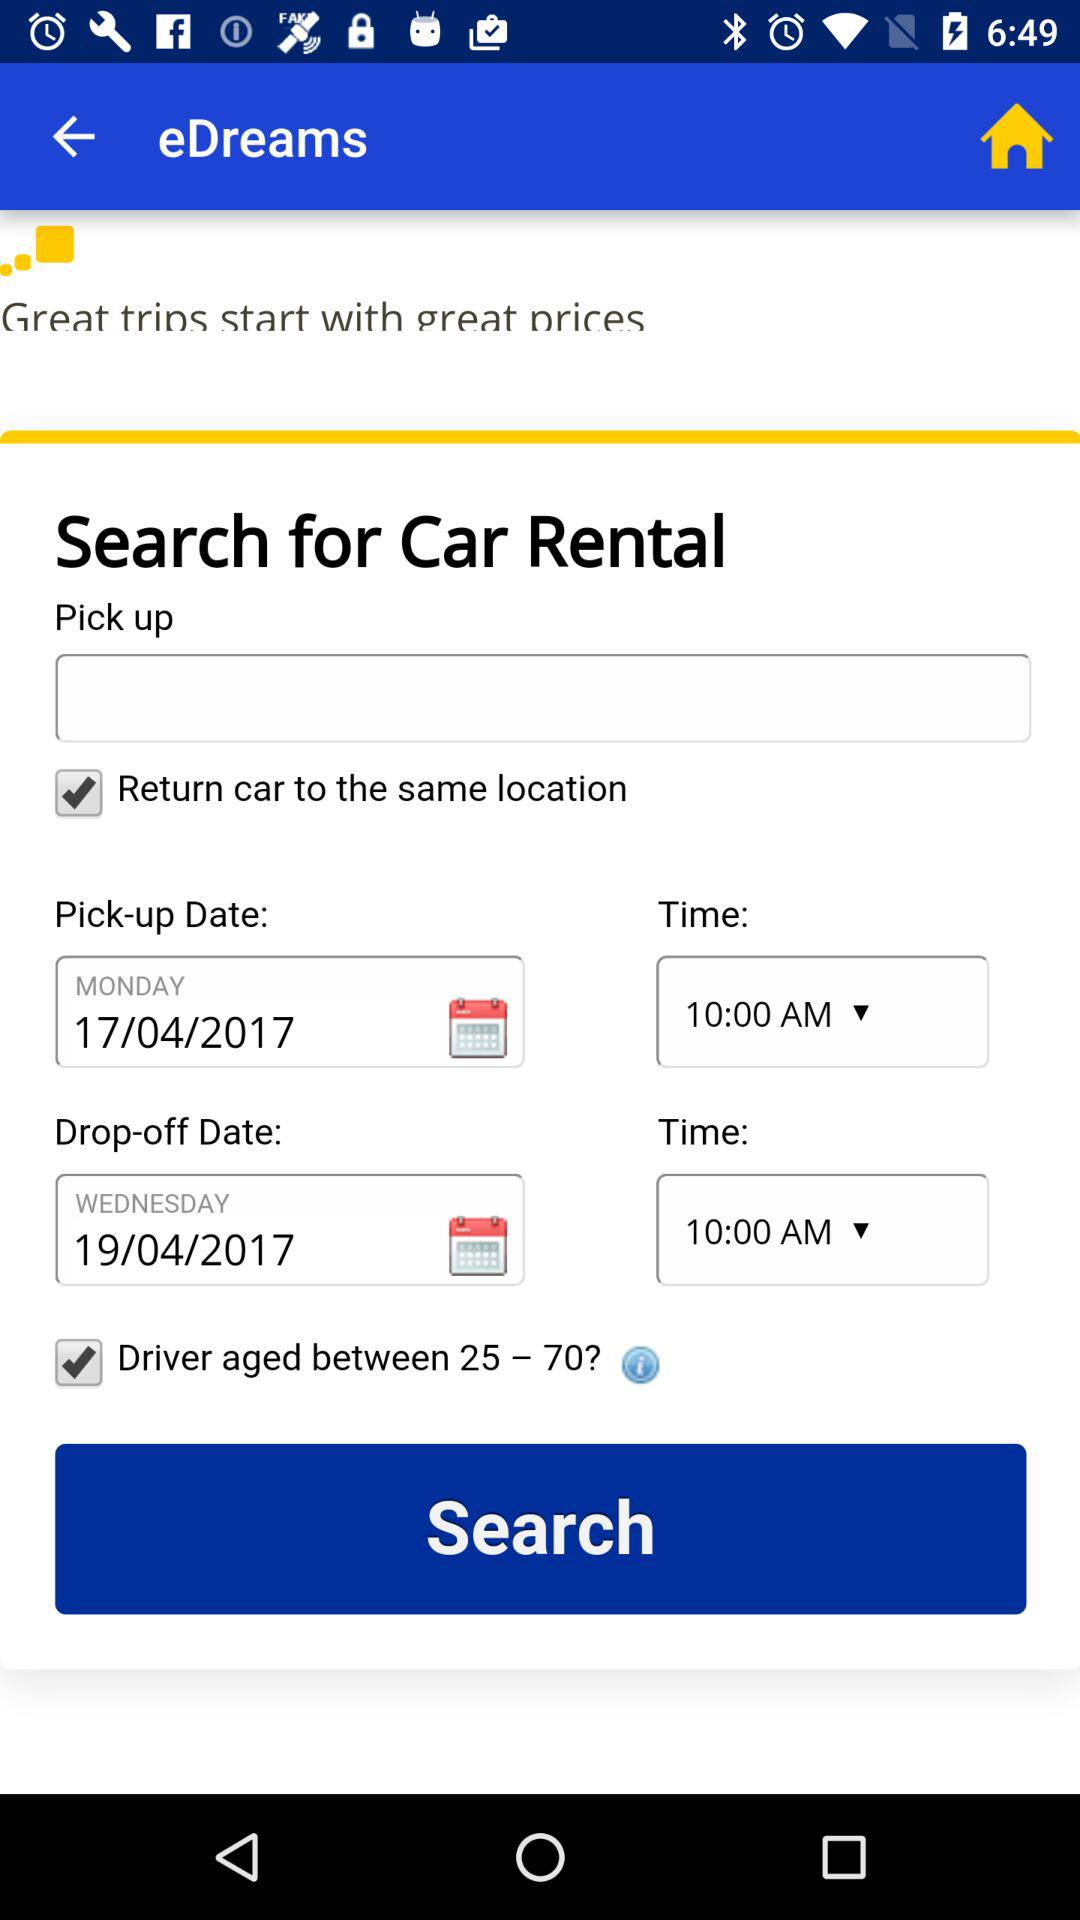What is the pick-up date? The pick-up date is Monday, April 17, 2017. 